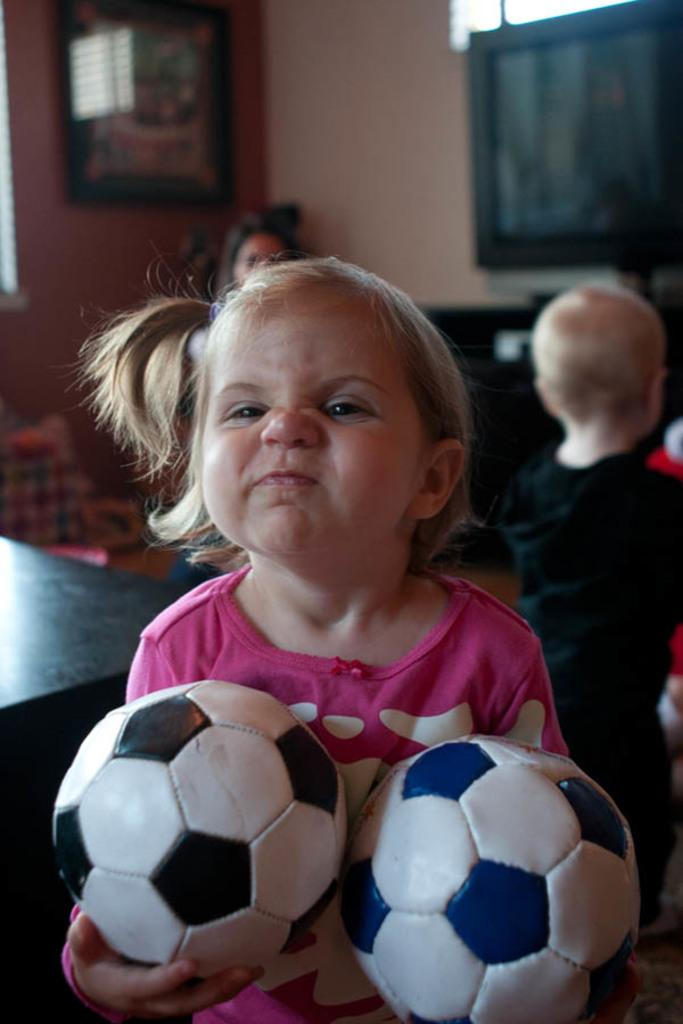Who is the main subject in the image? There is a girl in the image. What is the girl wearing? The girl is wearing a pink dress. What is the girl holding in her hands? The girl is holding two balls in her hands. What can be seen in the background of the image? There is a television and a wall in the background of the image. Are there any other people visible in the image? Yes, there are two more persons in the background of the image. What type of roof can be seen in the image? There is no roof visible in the image. What need does the girl have for the balls in her hands? The image does not provide any information about the girl's need for the balls; she is simply holding them. 